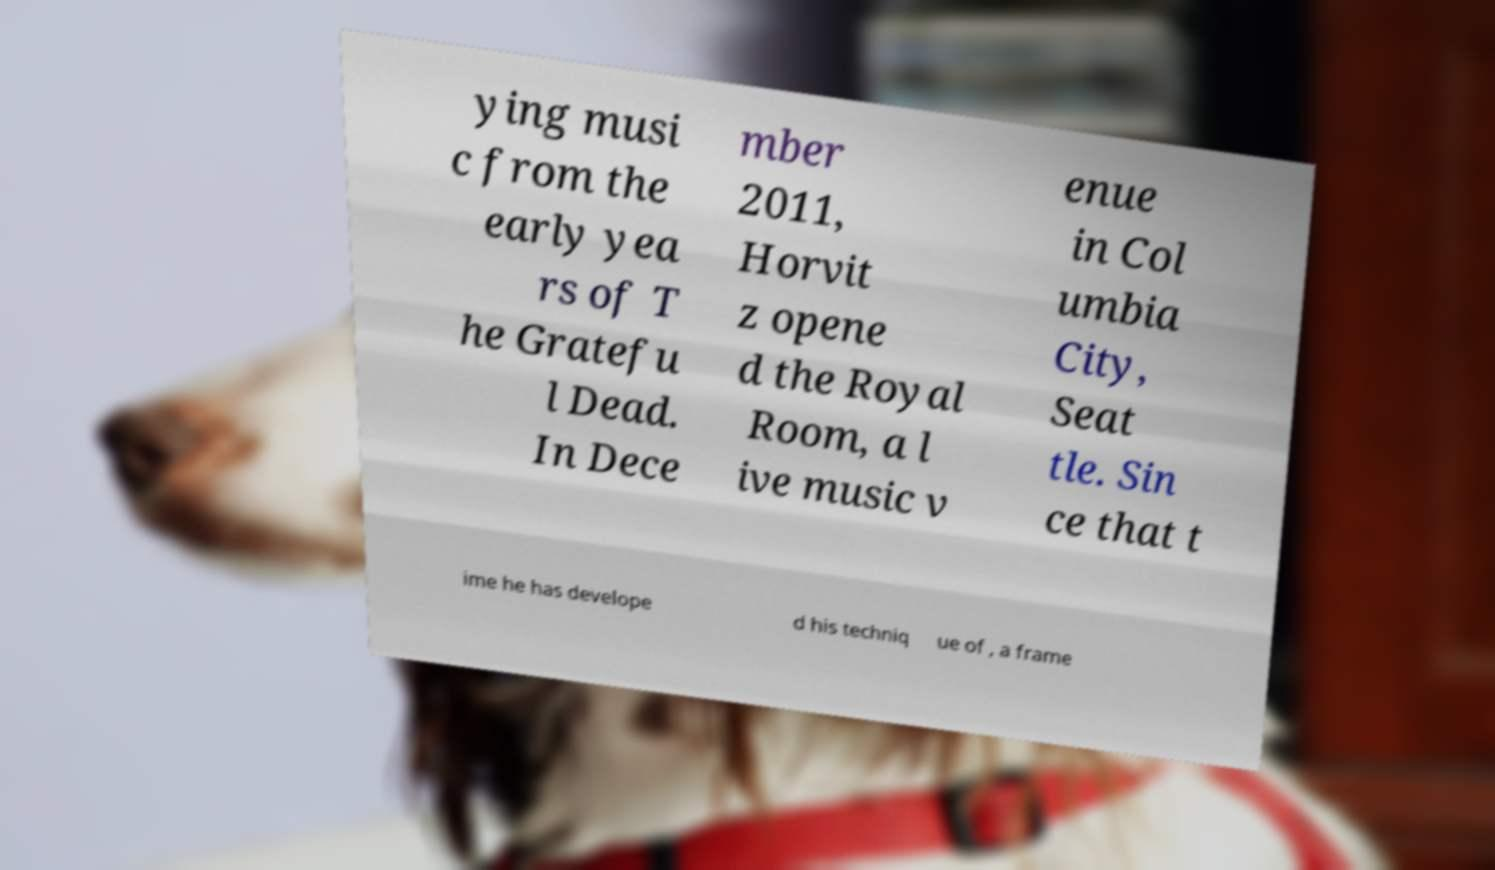Can you read and provide the text displayed in the image?This photo seems to have some interesting text. Can you extract and type it out for me? ying musi c from the early yea rs of T he Gratefu l Dead. In Dece mber 2011, Horvit z opene d the Royal Room, a l ive music v enue in Col umbia City, Seat tle. Sin ce that t ime he has develope d his techniq ue of , a frame 